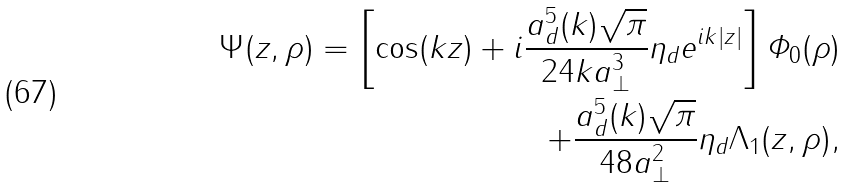<formula> <loc_0><loc_0><loc_500><loc_500>\Psi ( z , \rho ) = \left [ \cos ( k z ) + i \frac { a _ { d } ^ { 5 } ( k ) \sqrt { \pi } } { 2 4 k a _ { \perp } ^ { 3 } } \eta _ { d } e ^ { i k | z | } \right ] \varPhi _ { 0 } ( \rho ) \\ + \frac { a _ { d } ^ { 5 } ( k ) \sqrt { \pi } } { 4 8 a _ { \perp } ^ { 2 } } \eta _ { d } \Lambda _ { 1 } ( z , \rho ) ,</formula> 